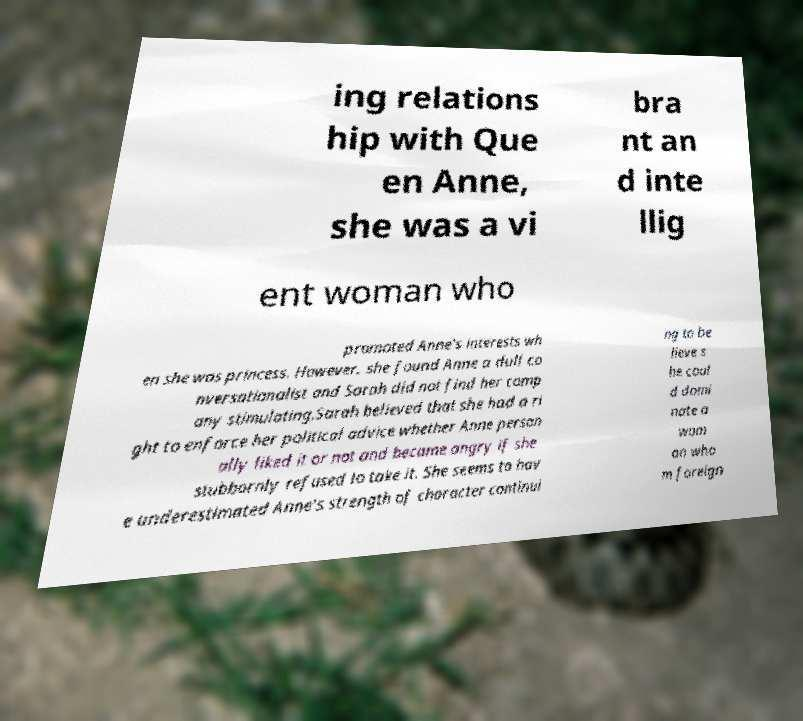There's text embedded in this image that I need extracted. Can you transcribe it verbatim? ing relations hip with Que en Anne, she was a vi bra nt an d inte llig ent woman who promoted Anne's interests wh en she was princess. However, she found Anne a dull co nversationalist and Sarah did not find her comp any stimulating.Sarah believed that she had a ri ght to enforce her political advice whether Anne person ally liked it or not and became angry if she stubbornly refused to take it. She seems to hav e underestimated Anne's strength of character continui ng to be lieve s he coul d domi nate a wom an who m foreign 